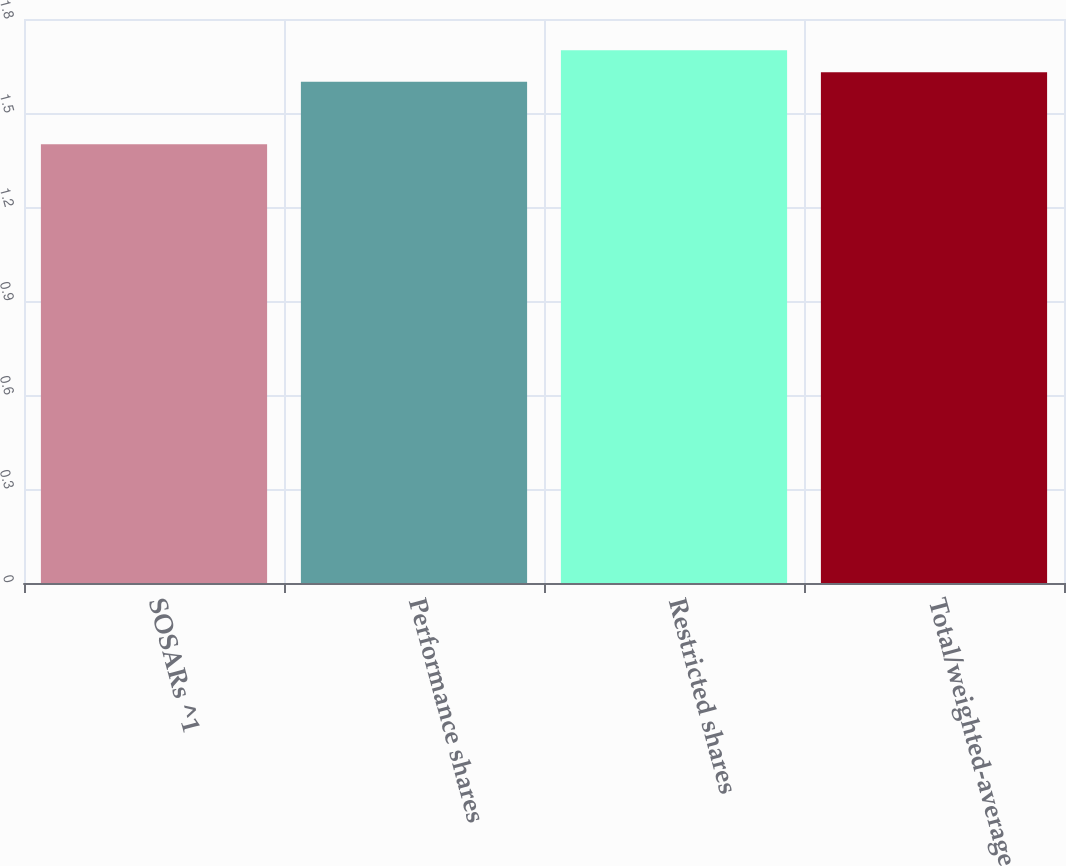Convert chart to OTSL. <chart><loc_0><loc_0><loc_500><loc_500><bar_chart><fcel>SOSARs ^1<fcel>Performance shares<fcel>Restricted shares<fcel>Total/weighted-average<nl><fcel>1.4<fcel>1.6<fcel>1.7<fcel>1.63<nl></chart> 